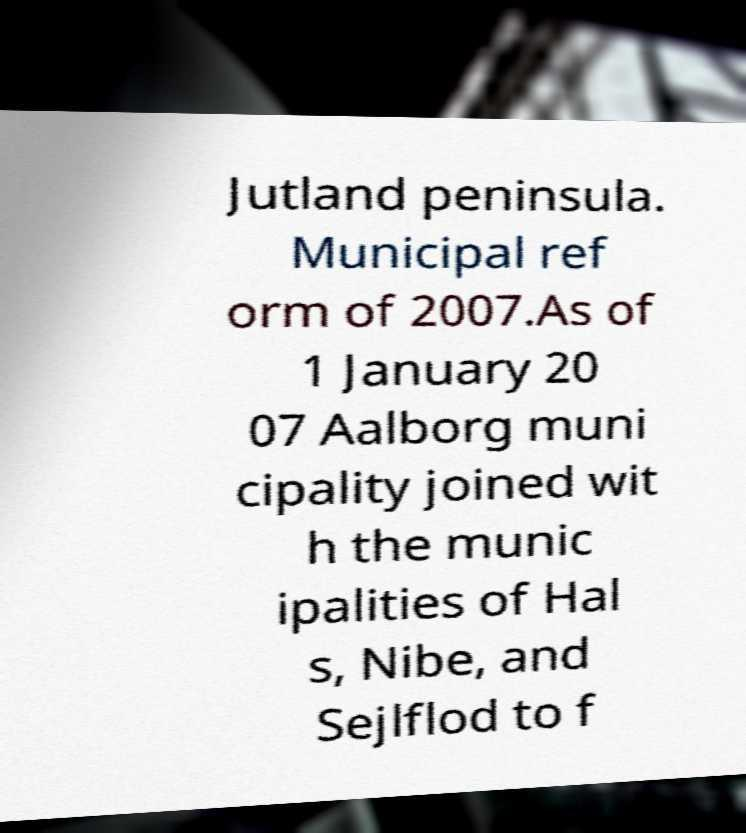Could you assist in decoding the text presented in this image and type it out clearly? Jutland peninsula. Municipal ref orm of 2007.As of 1 January 20 07 Aalborg muni cipality joined wit h the munic ipalities of Hal s, Nibe, and Sejlflod to f 